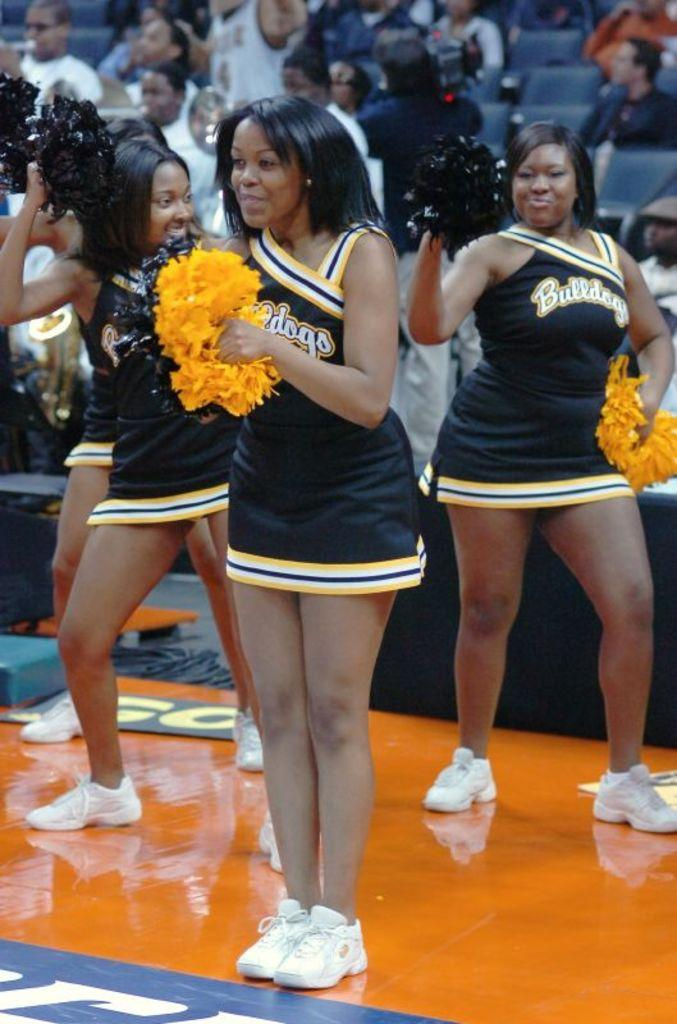<image>
Summarize the visual content of the image. Four women wearing a Bulldogs jersey cheerleading for an audience. 